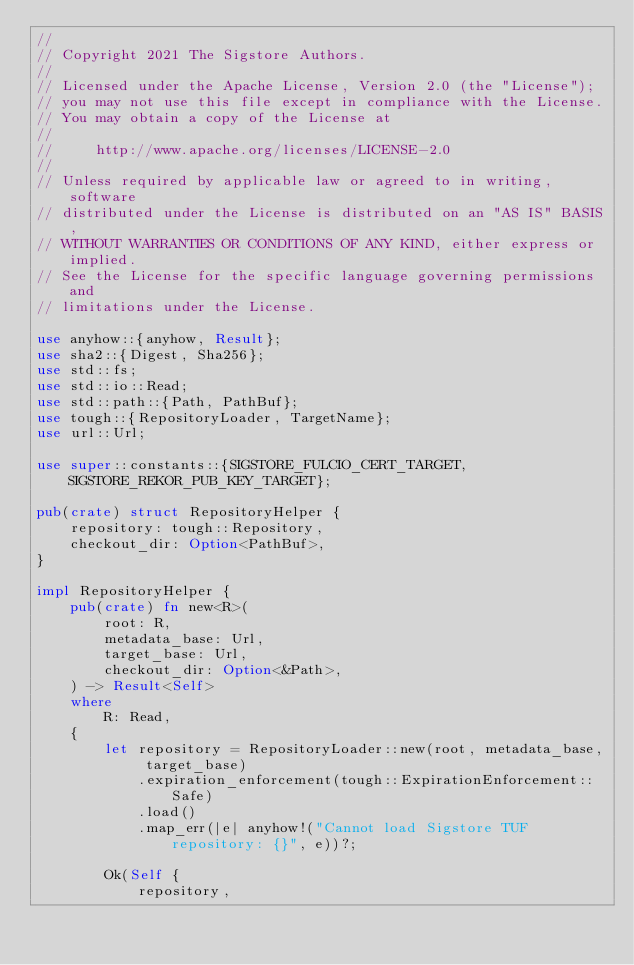Convert code to text. <code><loc_0><loc_0><loc_500><loc_500><_Rust_>//
// Copyright 2021 The Sigstore Authors.
//
// Licensed under the Apache License, Version 2.0 (the "License");
// you may not use this file except in compliance with the License.
// You may obtain a copy of the License at
//
//     http://www.apache.org/licenses/LICENSE-2.0
//
// Unless required by applicable law or agreed to in writing, software
// distributed under the License is distributed on an "AS IS" BASIS,
// WITHOUT WARRANTIES OR CONDITIONS OF ANY KIND, either express or implied.
// See the License for the specific language governing permissions and
// limitations under the License.

use anyhow::{anyhow, Result};
use sha2::{Digest, Sha256};
use std::fs;
use std::io::Read;
use std::path::{Path, PathBuf};
use tough::{RepositoryLoader, TargetName};
use url::Url;

use super::constants::{SIGSTORE_FULCIO_CERT_TARGET, SIGSTORE_REKOR_PUB_KEY_TARGET};

pub(crate) struct RepositoryHelper {
    repository: tough::Repository,
    checkout_dir: Option<PathBuf>,
}

impl RepositoryHelper {
    pub(crate) fn new<R>(
        root: R,
        metadata_base: Url,
        target_base: Url,
        checkout_dir: Option<&Path>,
    ) -> Result<Self>
    where
        R: Read,
    {
        let repository = RepositoryLoader::new(root, metadata_base, target_base)
            .expiration_enforcement(tough::ExpirationEnforcement::Safe)
            .load()
            .map_err(|e| anyhow!("Cannot load Sigstore TUF repository: {}", e))?;

        Ok(Self {
            repository,</code> 